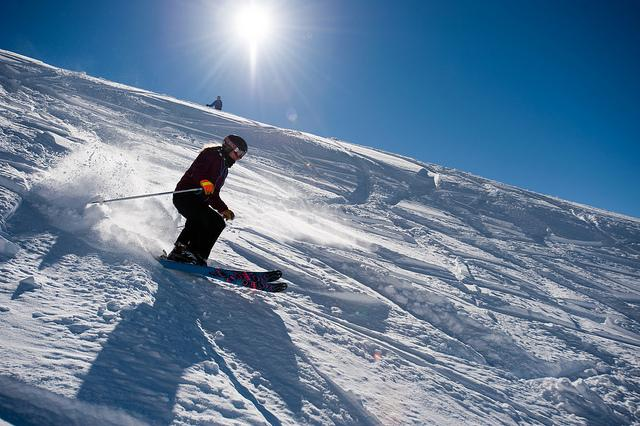Which EU country might be associated with the colors of the skier's gloves?

Choices:
A) france
B) croatia
C) poland
D) netherlands netherlands 